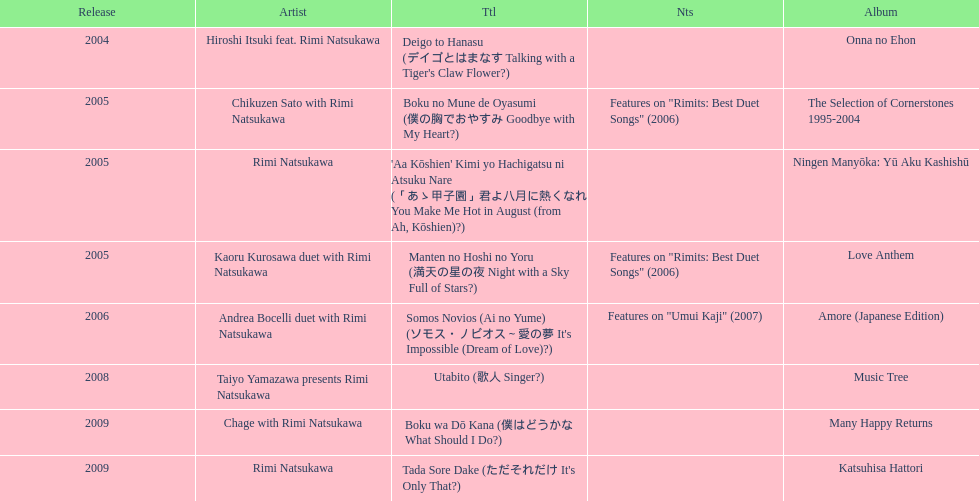What is the number of albums released with the artist rimi natsukawa? 8. 